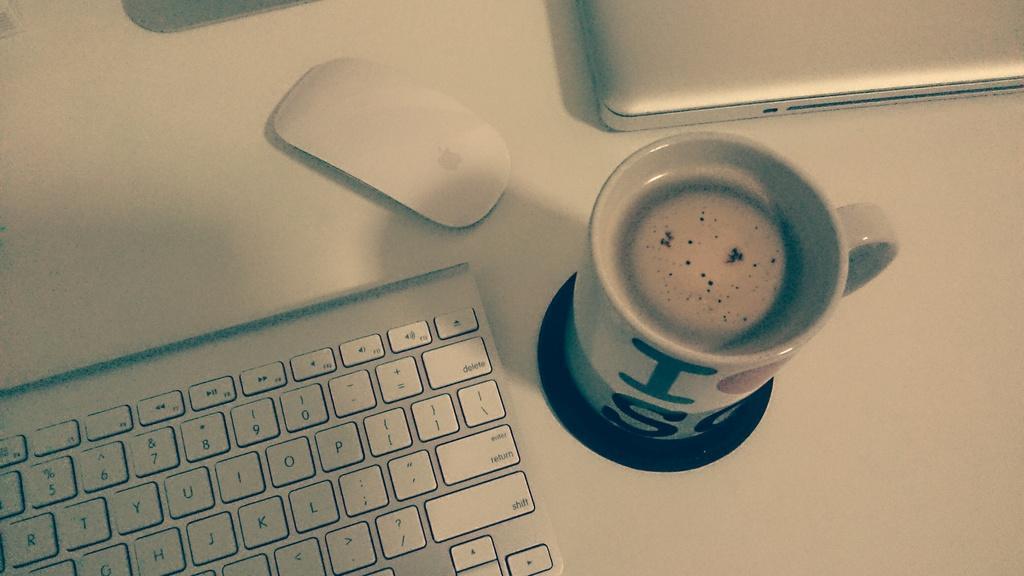Could you give a brief overview of what you see in this image? In the middle there is a coffee cup, on the left side there is a keyboard and here it is a mouse. 